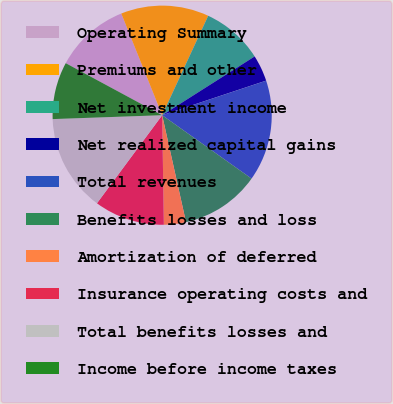<chart> <loc_0><loc_0><loc_500><loc_500><pie_chart><fcel>Operating Summary<fcel>Premiums and other<fcel>Net investment income<fcel>Net realized capital gains<fcel>Total revenues<fcel>Benefits losses and loss<fcel>Amortization of deferred<fcel>Insurance operating costs and<fcel>Total benefits losses and<fcel>Income before income taxes<nl><fcel>11.04%<fcel>12.99%<fcel>9.09%<fcel>3.9%<fcel>14.93%<fcel>11.69%<fcel>3.25%<fcel>10.39%<fcel>14.29%<fcel>8.44%<nl></chart> 